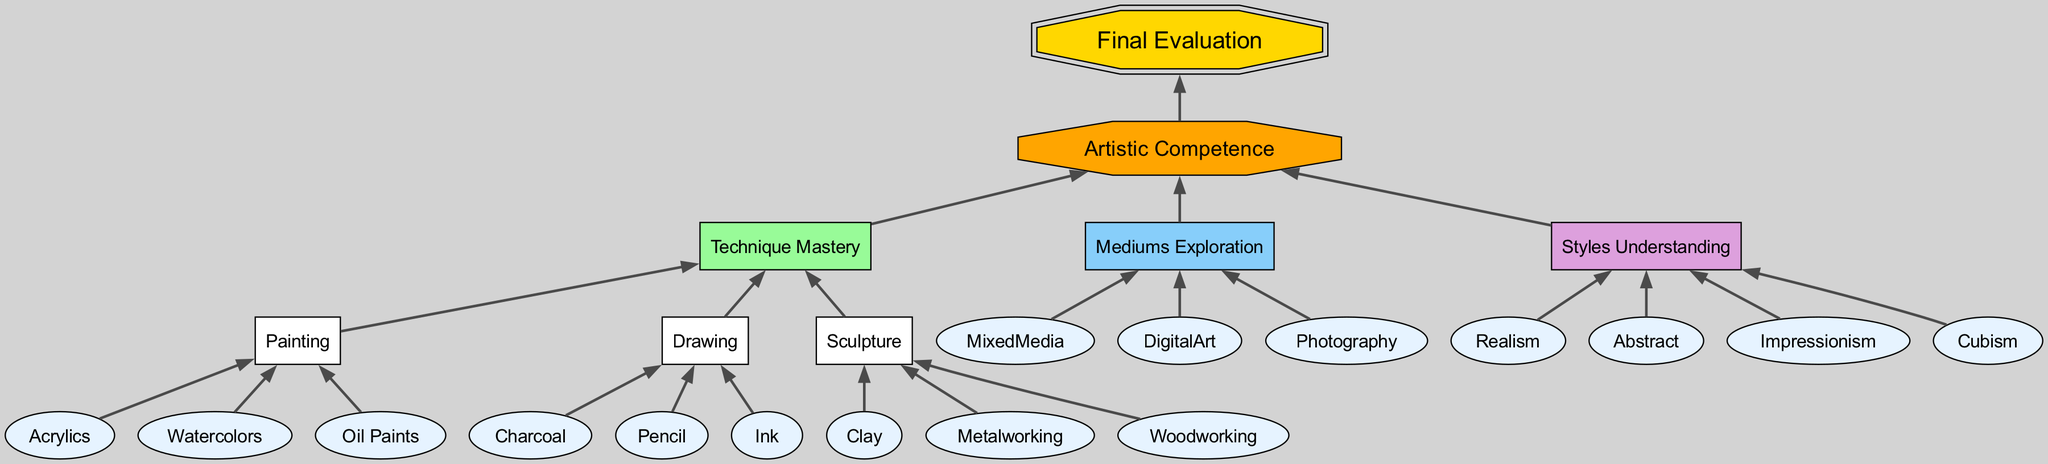What is the main category at the top of the diagram? The main category at the top of the diagram is labeled "Final Evaluation." This can be identified as the first node presented in the chart.
Answer: Final Evaluation How many artistic competence categories are there? There are three main categories under "Artistic Competence": Technique Mastery, Mediums Exploration, and Styles Understanding. Counting these nodes provides the total.
Answer: 3 Which technique is included under Technique Mastery? One of the techniques listed under Technique Mastery is "Drawing." This can be found as a subcategory under the Technique Mastery node in the diagram.
Answer: Drawing What is the last style listed in Styles Understanding? The last style listed under Styles Understanding is "Cubism." By examining the order of the nodes beneath this category, it is the final entry.
Answer: Cubism How many different painting mediums are shown? There are three different painting mediums displayed: Acrylics, Watercolors, and Oil Paints. Counting these nodes under Painting in the Technique Mastery section gives the total.
Answer: 3 What type of artistic technique does "Metalworking" belong to? "Metalworking" belongs to the artistic technique category of "Sculpture." This relationship is depicted in a hierarchical manner in the flowchart.
Answer: Sculpture Which artistic category does "Photography" fall under? "Photography" is classified under "Mediums Exploration." This can be determined by locating Photography within the Mediums Exploration section of the diagram.
Answer: Mediums Exploration How many mediums are explored in total? The total number of mediums explored in the chart includes Mixed Media, Digital Art, and Photography. Thus, there are three mediums in total.
Answer: 3 What artistic style is categorized as a form of realism? The artistic style categorized as a form of realism is "Realism" itself. This is directly stated as one of the node entries in the Styles Understanding section.
Answer: Realism 